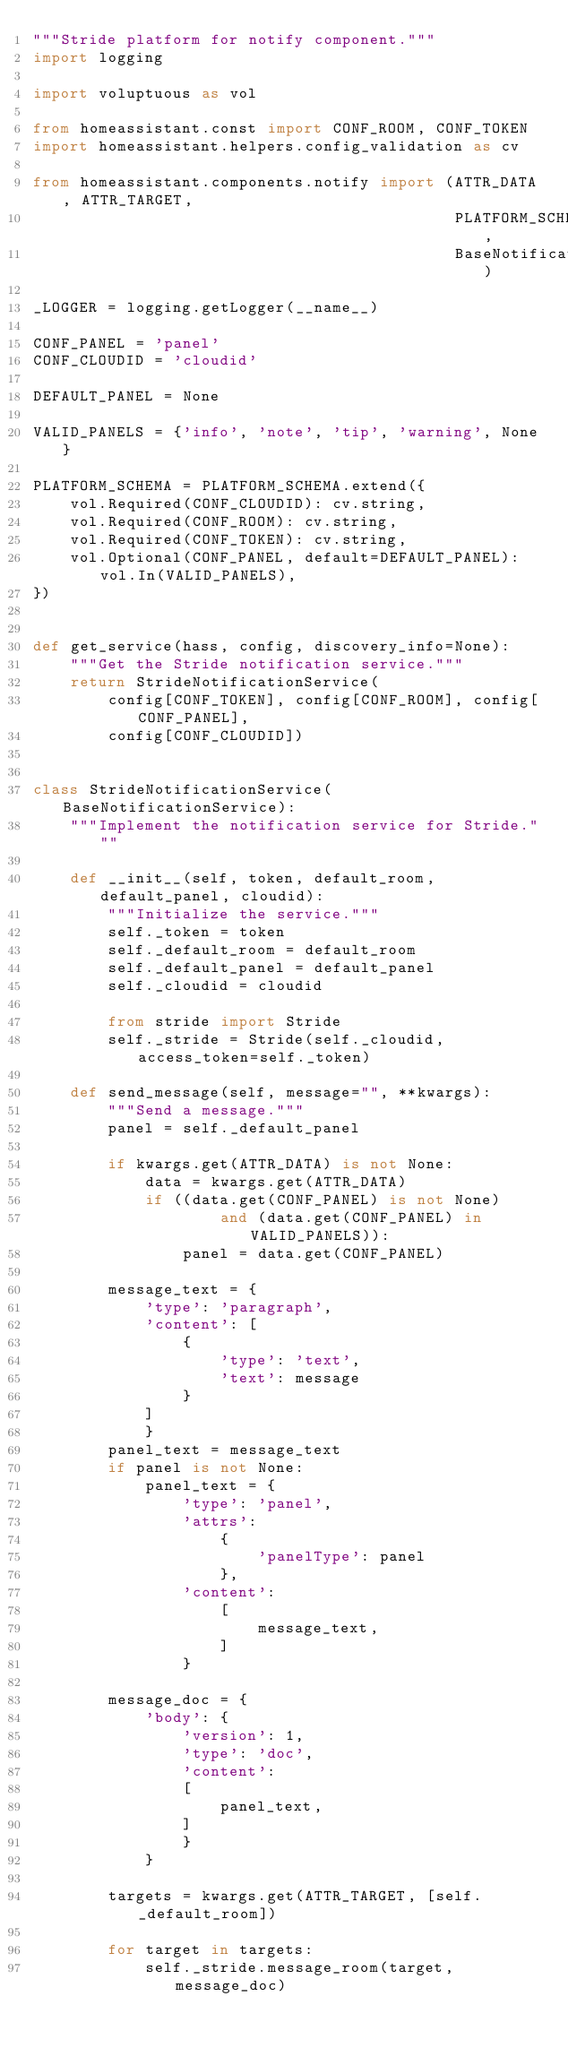<code> <loc_0><loc_0><loc_500><loc_500><_Python_>"""Stride platform for notify component."""
import logging

import voluptuous as vol

from homeassistant.const import CONF_ROOM, CONF_TOKEN
import homeassistant.helpers.config_validation as cv

from homeassistant.components.notify import (ATTR_DATA, ATTR_TARGET,
                                             PLATFORM_SCHEMA,
                                             BaseNotificationService)

_LOGGER = logging.getLogger(__name__)

CONF_PANEL = 'panel'
CONF_CLOUDID = 'cloudid'

DEFAULT_PANEL = None

VALID_PANELS = {'info', 'note', 'tip', 'warning', None}

PLATFORM_SCHEMA = PLATFORM_SCHEMA.extend({
    vol.Required(CONF_CLOUDID): cv.string,
    vol.Required(CONF_ROOM): cv.string,
    vol.Required(CONF_TOKEN): cv.string,
    vol.Optional(CONF_PANEL, default=DEFAULT_PANEL): vol.In(VALID_PANELS),
})


def get_service(hass, config, discovery_info=None):
    """Get the Stride notification service."""
    return StrideNotificationService(
        config[CONF_TOKEN], config[CONF_ROOM], config[CONF_PANEL],
        config[CONF_CLOUDID])


class StrideNotificationService(BaseNotificationService):
    """Implement the notification service for Stride."""

    def __init__(self, token, default_room, default_panel, cloudid):
        """Initialize the service."""
        self._token = token
        self._default_room = default_room
        self._default_panel = default_panel
        self._cloudid = cloudid

        from stride import Stride
        self._stride = Stride(self._cloudid, access_token=self._token)

    def send_message(self, message="", **kwargs):
        """Send a message."""
        panel = self._default_panel

        if kwargs.get(ATTR_DATA) is not None:
            data = kwargs.get(ATTR_DATA)
            if ((data.get(CONF_PANEL) is not None)
                    and (data.get(CONF_PANEL) in VALID_PANELS)):
                panel = data.get(CONF_PANEL)

        message_text = {
            'type': 'paragraph',
            'content': [
                {
                    'type': 'text',
                    'text': message
                }
            ]
            }
        panel_text = message_text
        if panel is not None:
            panel_text = {
                'type': 'panel',
                'attrs':
                    {
                        'panelType': panel
                    },
                'content':
                    [
                        message_text,
                    ]
                }

        message_doc = {
            'body': {
                'version': 1,
                'type': 'doc',
                'content':
                [
                    panel_text,
                ]
                }
            }

        targets = kwargs.get(ATTR_TARGET, [self._default_room])

        for target in targets:
            self._stride.message_room(target, message_doc)
</code> 